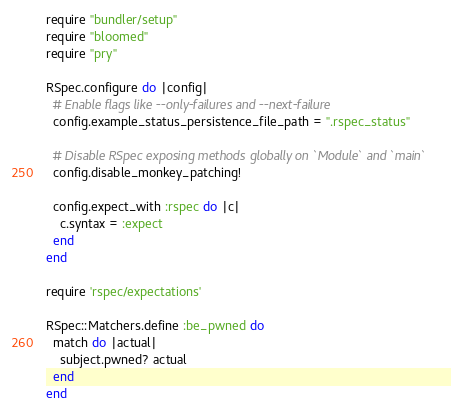<code> <loc_0><loc_0><loc_500><loc_500><_Ruby_>require "bundler/setup"
require "bloomed"
require "pry"

RSpec.configure do |config|
  # Enable flags like --only-failures and --next-failure
  config.example_status_persistence_file_path = ".rspec_status"

  # Disable RSpec exposing methods globally on `Module` and `main`
  config.disable_monkey_patching!

  config.expect_with :rspec do |c|
    c.syntax = :expect
  end
end

require 'rspec/expectations'

RSpec::Matchers.define :be_pwned do
  match do |actual|
    subject.pwned? actual
  end
end
</code> 